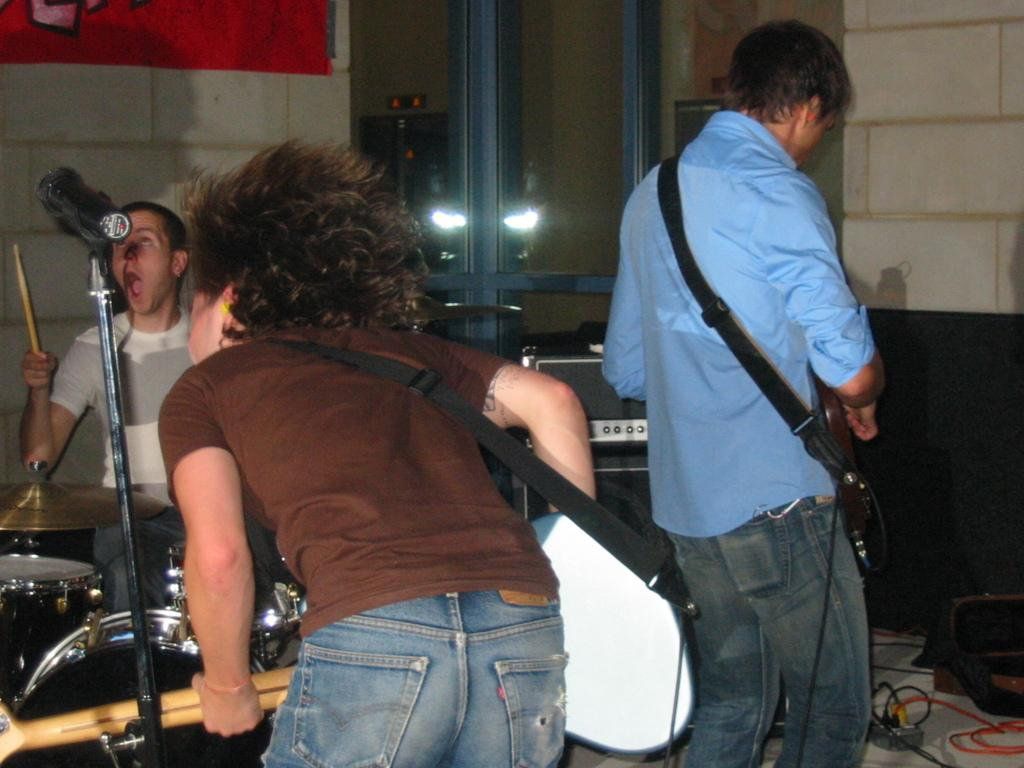How many people are in the image? There are three persons in the image. What are the persons doing in the image? The persons are holding musical instruments. Can you describe the positions of the persons in the image? Two of the persons are standing. What can be seen in the background of the image? There is a wall and a cloth visible in the background of the image. What type of government is depicted in the image? There is no depiction of a government in the image; it features three persons holding musical instruments. What is the reaction of the chain to the music being played in the image? There is no chain present in the image, so it is not possible to determine its reaction to any music being played. 